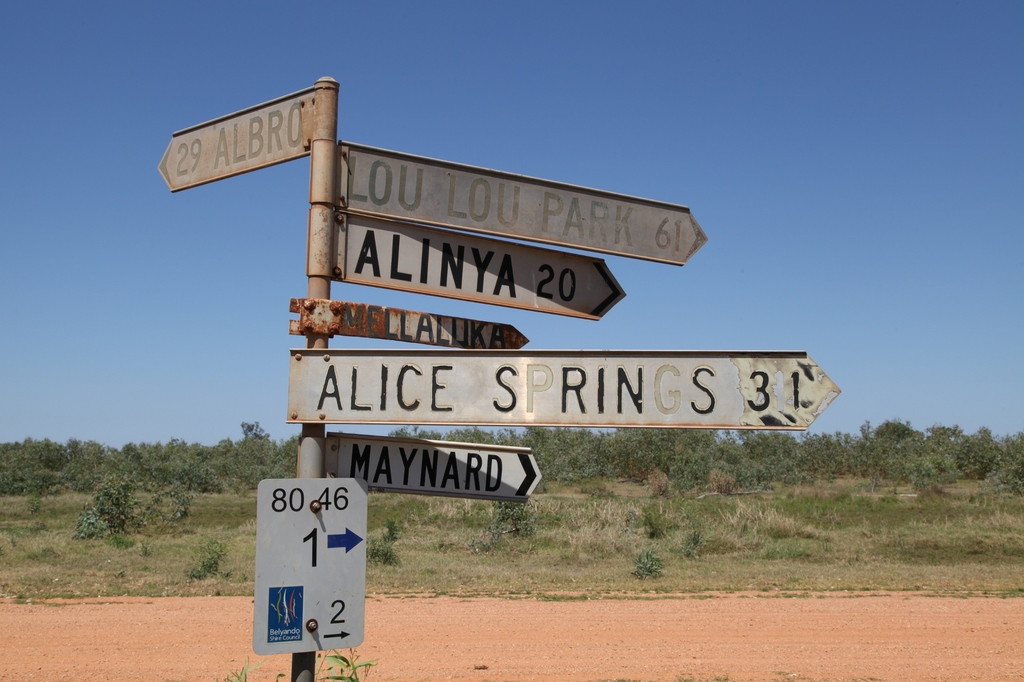What might the numbers 80 and 46 mean on this blue sign? The numbers '80' and '46' on the blue sign could likely be part of a route or road numbering system, which is common in many regions to help drivers navigate. These numbers could refer to the specific routes on which the signpost is placed, assisting travelers in identifying their current road or the roads branching off from the main route. Such signage is integral in areas like the outback, where long stretches of road might not have many distinguishing features. 